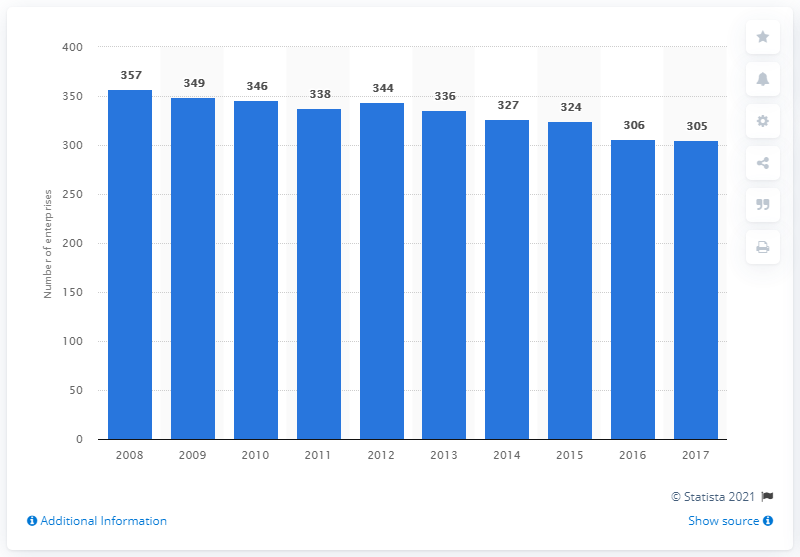Indicate a few pertinent items in this graphic. In 2017, there were 305 enterprises in Norway that manufactured plastics products. 